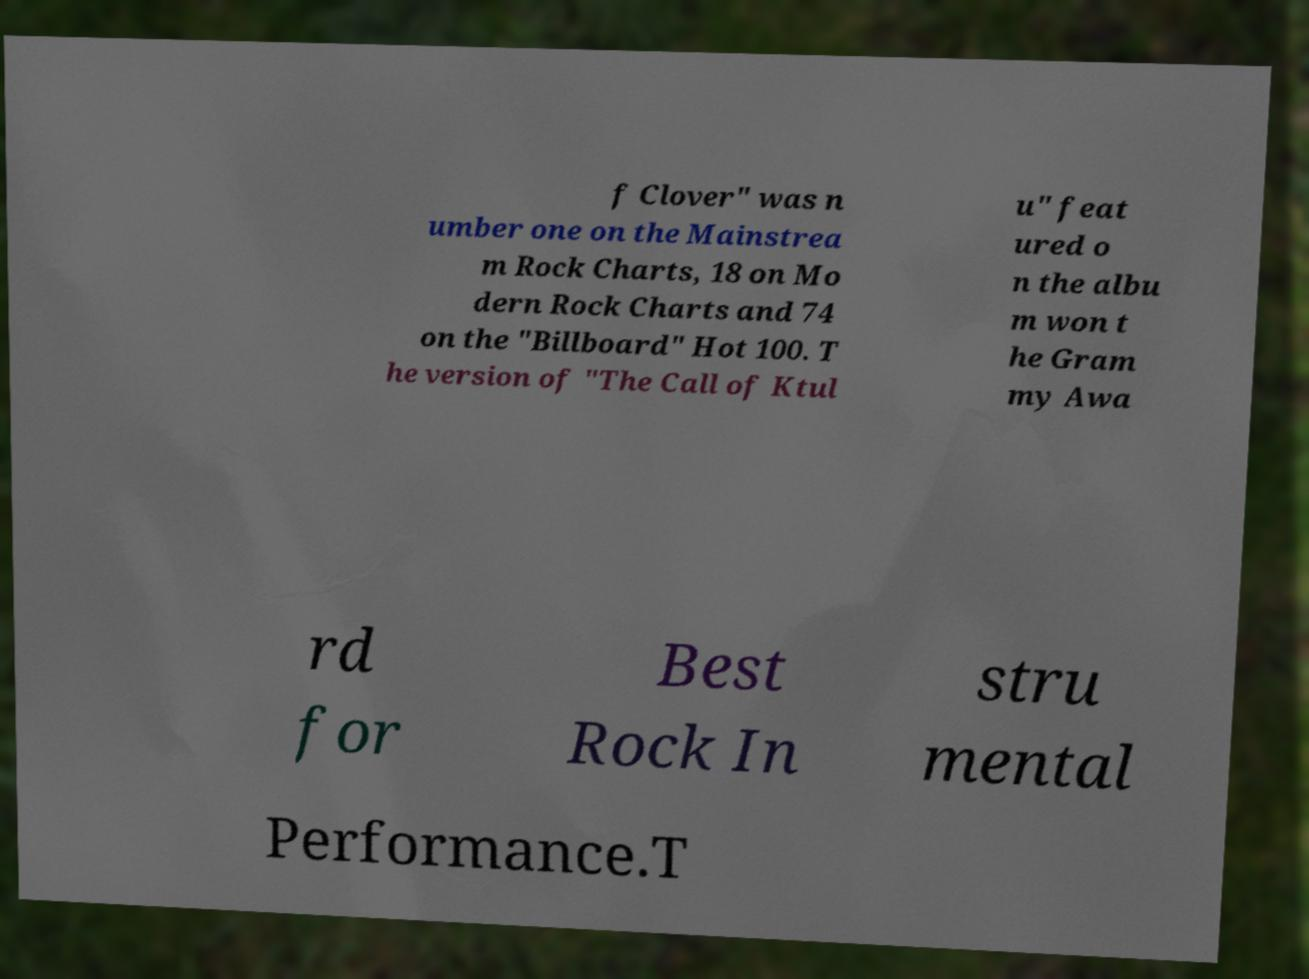There's text embedded in this image that I need extracted. Can you transcribe it verbatim? f Clover" was n umber one on the Mainstrea m Rock Charts, 18 on Mo dern Rock Charts and 74 on the "Billboard" Hot 100. T he version of "The Call of Ktul u" feat ured o n the albu m won t he Gram my Awa rd for Best Rock In stru mental Performance.T 